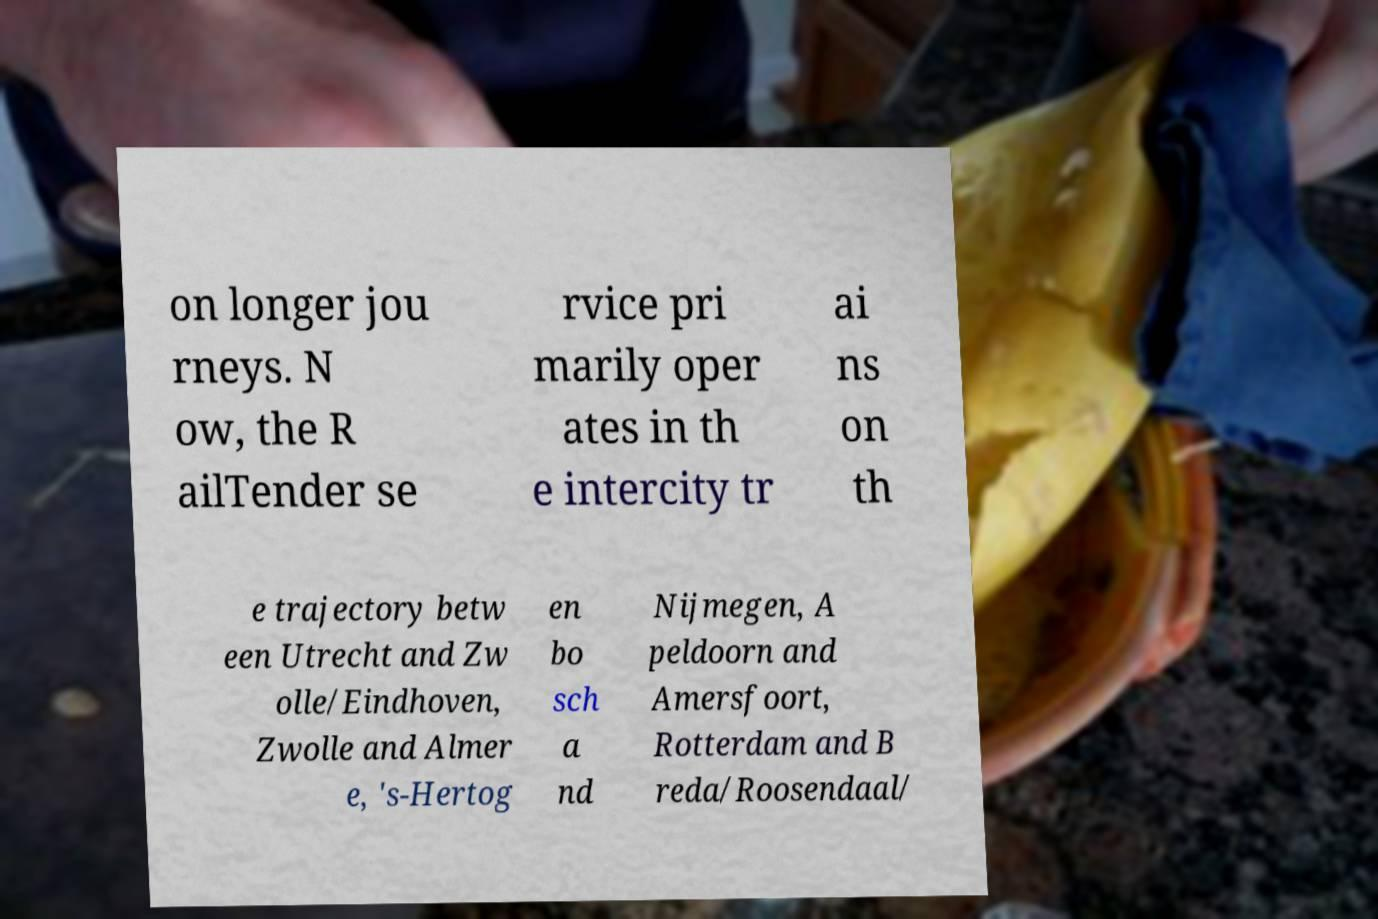Could you assist in decoding the text presented in this image and type it out clearly? on longer jou rneys. N ow, the R ailTender se rvice pri marily oper ates in th e intercity tr ai ns on th e trajectory betw een Utrecht and Zw olle/Eindhoven, Zwolle and Almer e, 's-Hertog en bo sch a nd Nijmegen, A peldoorn and Amersfoort, Rotterdam and B reda/Roosendaal/ 